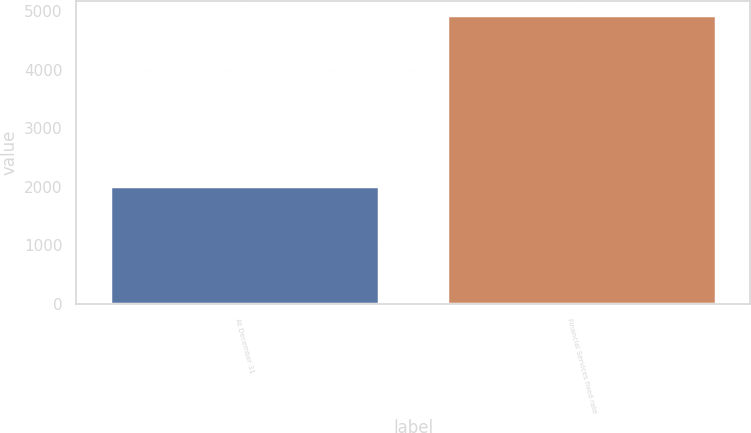<chart> <loc_0><loc_0><loc_500><loc_500><bar_chart><fcel>At December 31<fcel>Financial Services fixed rate<nl><fcel>2016<fcel>4929.3<nl></chart> 